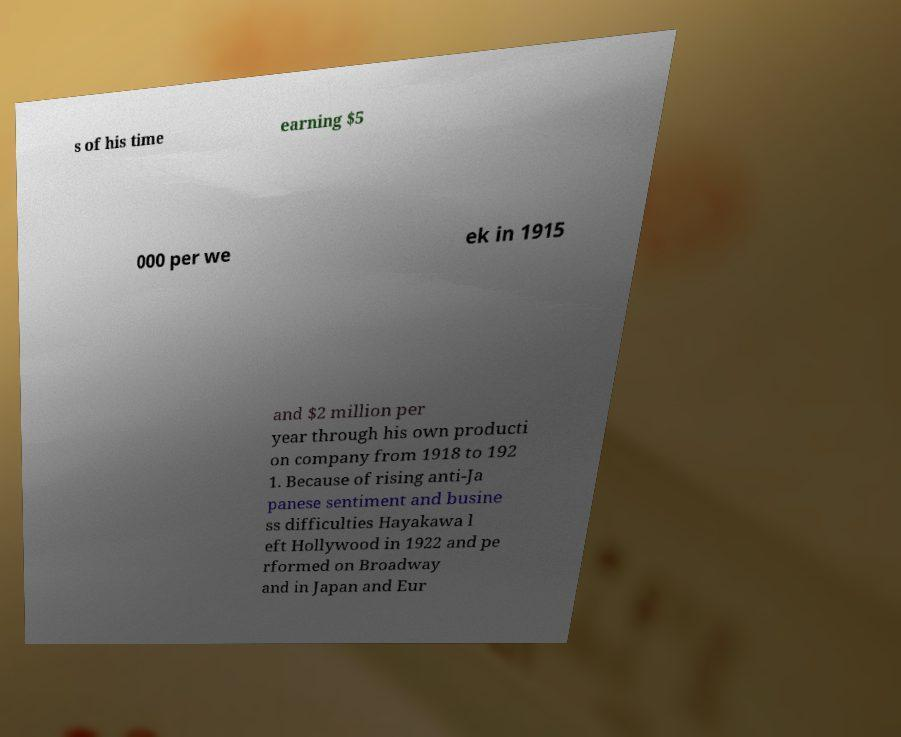What messages or text are displayed in this image? I need them in a readable, typed format. s of his time earning $5 000 per we ek in 1915 and $2 million per year through his own producti on company from 1918 to 192 1. Because of rising anti-Ja panese sentiment and busine ss difficulties Hayakawa l eft Hollywood in 1922 and pe rformed on Broadway and in Japan and Eur 